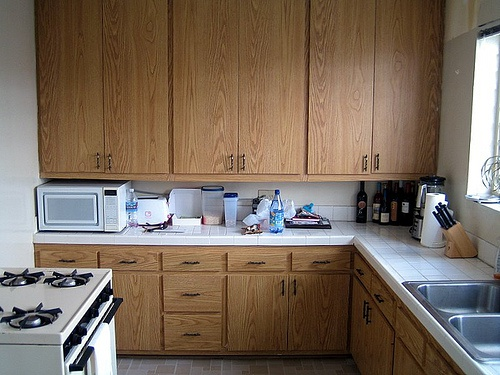Describe the objects in this image and their specific colors. I can see oven in gray, darkgray, black, and white tones, sink in gray and darkblue tones, microwave in gray, darkgray, lightgray, and lightblue tones, bottle in gray, black, and lightblue tones, and toaster in gray, lavender, lightblue, darkgray, and black tones in this image. 